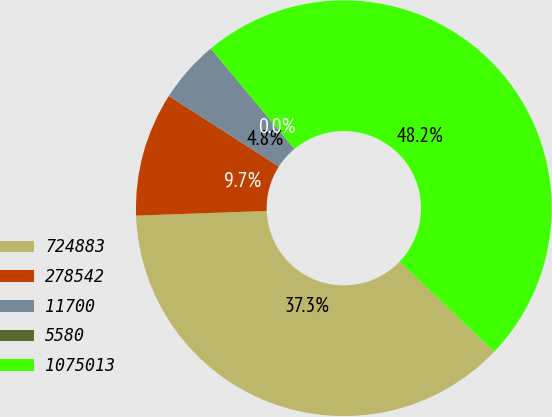<chart> <loc_0><loc_0><loc_500><loc_500><pie_chart><fcel>724883<fcel>278542<fcel>11700<fcel>5580<fcel>1075013<nl><fcel>37.3%<fcel>9.65%<fcel>4.84%<fcel>0.02%<fcel>48.18%<nl></chart> 